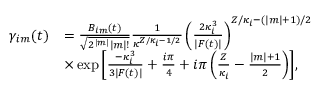<formula> <loc_0><loc_0><loc_500><loc_500>\begin{array} { r l } { \gamma _ { i m } ( t ) } & { = \frac { B _ { i m } ( t ) } { \sqrt { 2 ^ { | m | } | m | ! } } \frac { 1 } { \kappa ^ { Z / \kappa _ { i } - 1 / 2 } } \left ( \frac { 2 \kappa _ { i } ^ { 3 } } { | F ( t ) | } \right ) ^ { Z / \kappa _ { i } - ( | m | + 1 ) / 2 } } \\ & { \times \exp { \left [ \frac { - \kappa _ { i } ^ { 3 } } { 3 | F ( t ) | } + \frac { i \pi } { 4 } + i \pi \left ( \frac { Z } { \kappa _ { i } } - \frac { | m | + 1 } { 2 } \right ) \right ] } , } \end{array}</formula> 